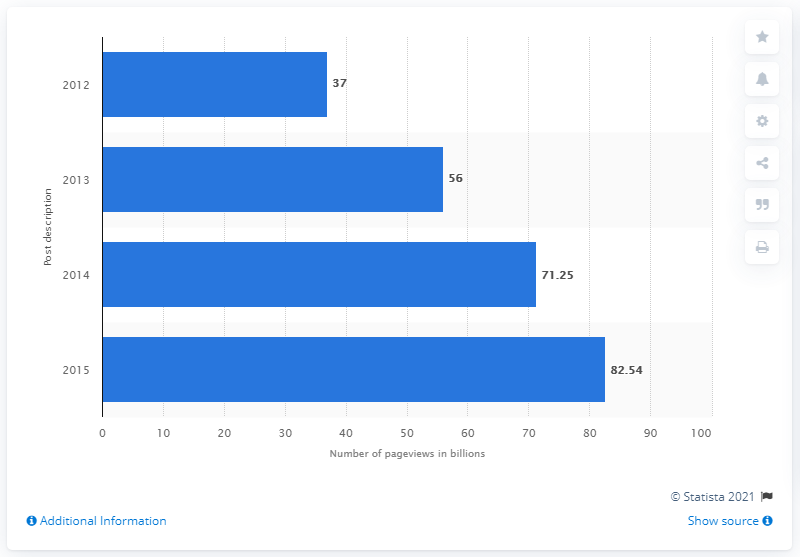Specify some key components in this picture. Reddit received 71.25 pageviews in the previous year. In 2015, Reddit received a total of 82.54 pageviews. 